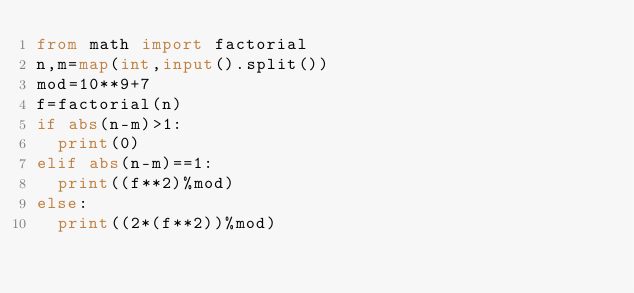Convert code to text. <code><loc_0><loc_0><loc_500><loc_500><_Python_>from math import factorial
n,m=map(int,input().split())
mod=10**9+7
f=factorial(n)
if abs(n-m)>1:
  print(0)
elif abs(n-m)==1:
  print((f**2)%mod)
else:
  print((2*(f**2))%mod)
</code> 